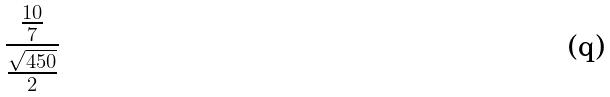<formula> <loc_0><loc_0><loc_500><loc_500>\frac { \frac { 1 0 } { 7 } } { \frac { \sqrt { 4 5 0 } } { 2 } }</formula> 